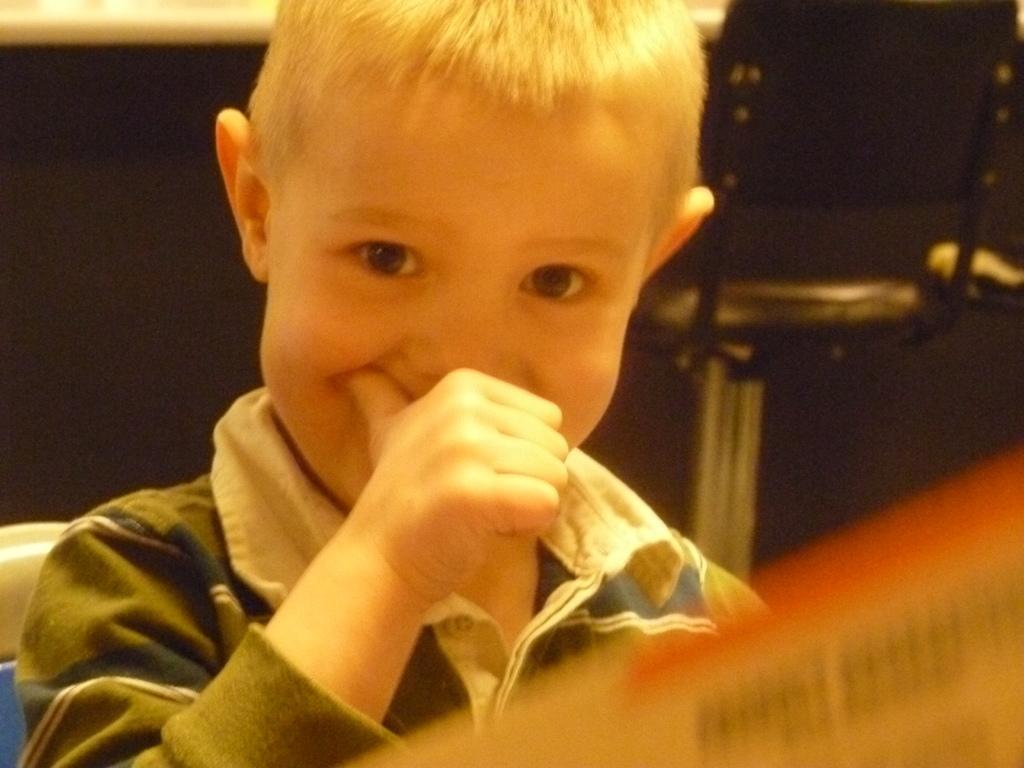Can you describe this image briefly? In this picture I can see a boy, and there is blur background. 